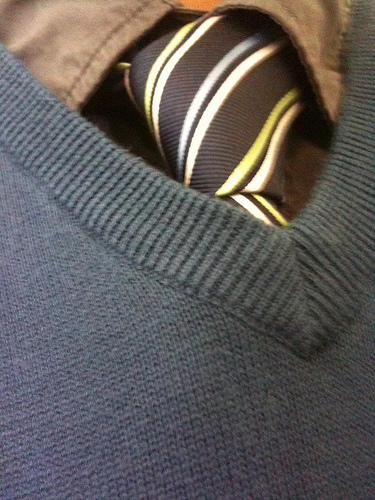Question: what kind of collar is the outer shirt?
Choices:
A. No collar.
B. Ruffled.
C. V-neck.
D. Ripped.
Answer with the letter. Answer: C 